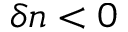<formula> <loc_0><loc_0><loc_500><loc_500>\delta n < 0</formula> 